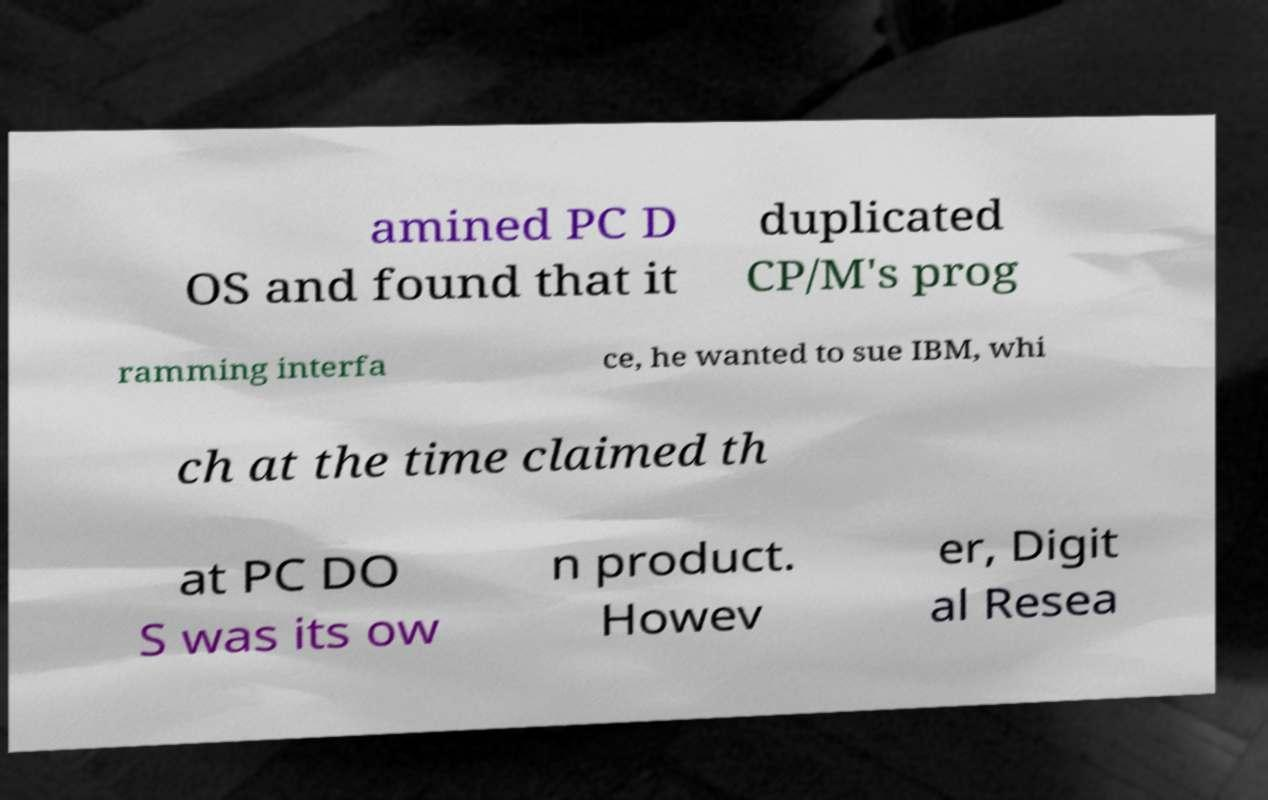Please identify and transcribe the text found in this image. amined PC D OS and found that it duplicated CP/M's prog ramming interfa ce, he wanted to sue IBM, whi ch at the time claimed th at PC DO S was its ow n product. Howev er, Digit al Resea 